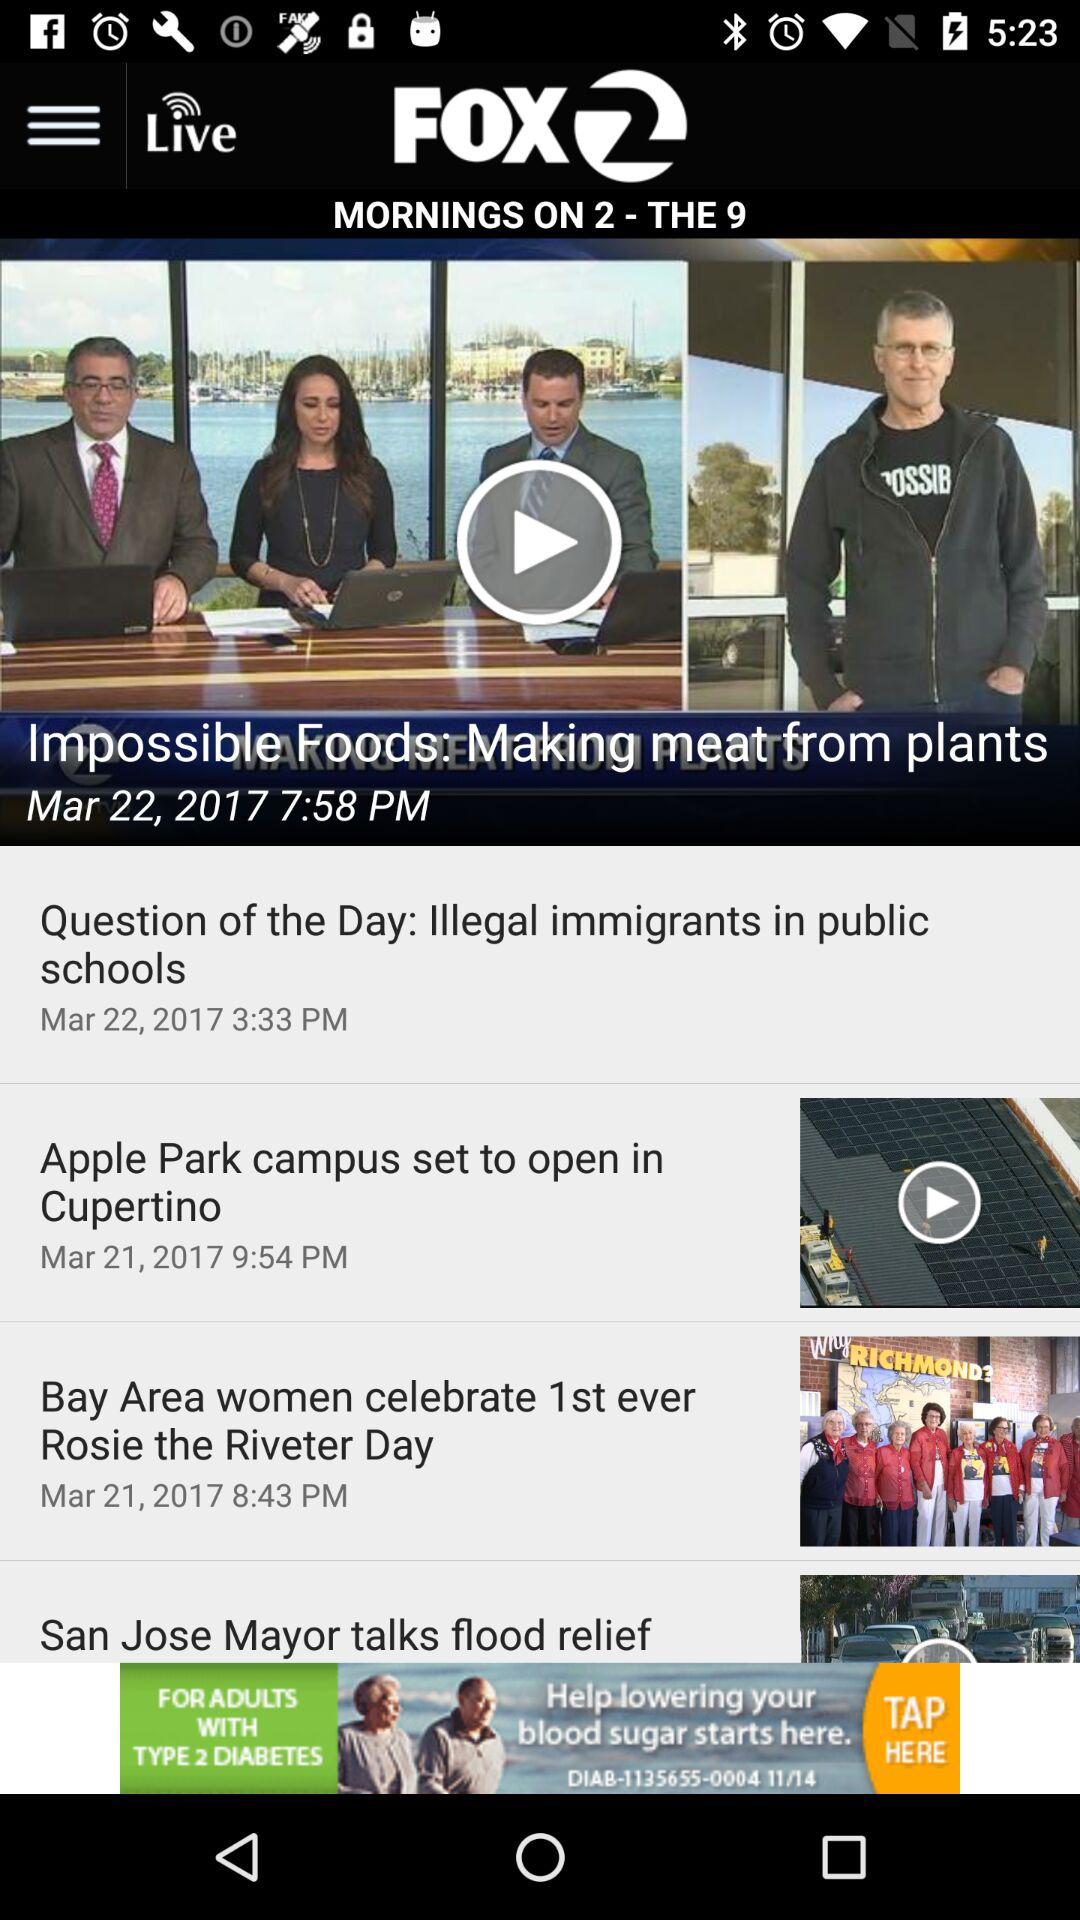What is the posting time for the "Question of the Day: Illegal immigrants in public schools"? The posting time is 3:33 pm. 